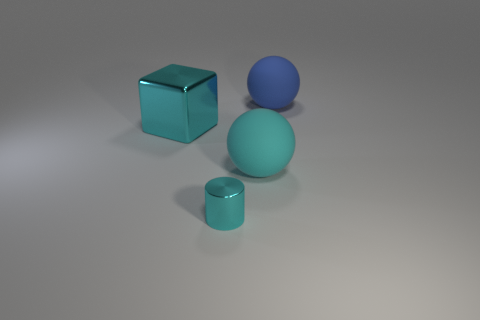Subtract all blue spheres. How many spheres are left? 1 Subtract 1 cylinders. How many cylinders are left? 0 Add 3 large yellow metal blocks. How many objects exist? 7 Subtract all cylinders. How many objects are left? 3 Subtract all gray balls. Subtract all green cubes. How many balls are left? 2 Subtract all yellow cylinders. How many gray cubes are left? 0 Subtract all matte objects. Subtract all big metallic blocks. How many objects are left? 1 Add 3 tiny shiny cylinders. How many tiny shiny cylinders are left? 4 Add 3 tiny cyan metallic cylinders. How many tiny cyan metallic cylinders exist? 4 Subtract 1 cyan balls. How many objects are left? 3 